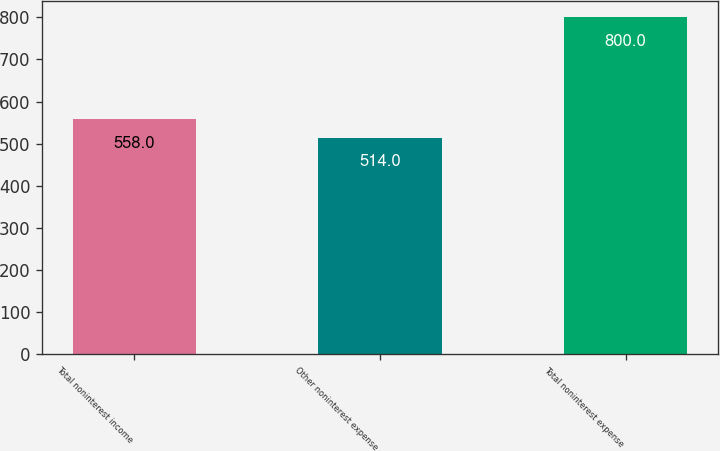<chart> <loc_0><loc_0><loc_500><loc_500><bar_chart><fcel>Total noninterest income<fcel>Other noninterest expense<fcel>Total noninterest expense<nl><fcel>558<fcel>514<fcel>800<nl></chart> 